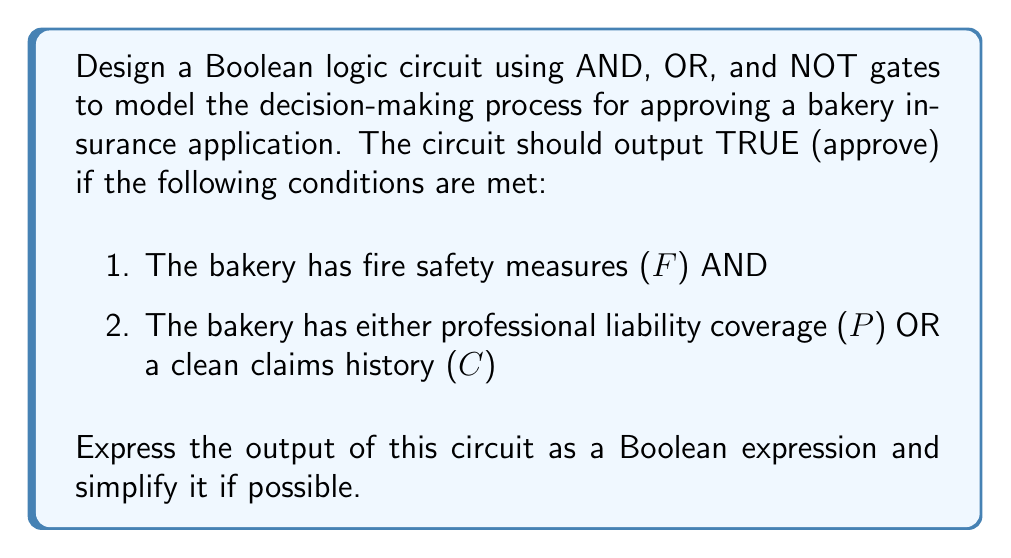Provide a solution to this math problem. Let's approach this step-by-step:

1) First, we need to translate the given conditions into a Boolean expression:

   Output = F AND (P OR C)

2) This can be represented in Boolean algebra as:

   $$Output = F \cdot (P + C)$$

3) To create a logic circuit for this expression:
   - We need an OR gate for (P + C)
   - We need an AND gate to combine F with the result of (P + C)

4) The circuit would look like this:

   [asy]
   import geometry;

   // Define points
   pair A = (0,0), B = (0,40), C = (40,20), D = (80,20), E = (120,20);

   // Draw OR gate
   draw(A--B--C--cycle);
   label("OR", (20,20));

   // Draw AND gate
   draw(D--E--(120,40)--(80,40)--cycle);
   path p = (80,30)..(100,20)..(80,10);
   draw(p);
   label("AND", (100,30));

   // Draw inputs and output
   draw((-20,0)--(0,0), arrow=Arrow(TeXHead));
   draw((-20,40)--(0,40), arrow=Arrow(TeXHead));
   draw((40,20)--(80,10), arrow=Arrow(TeXHead));
   draw((-20,70)--(80,70)--(80,30), arrow=Arrow(TeXHead));
   draw((120,20)--(140,20), arrow=Arrow(TeXHead));

   // Label inputs and output
   label("P", (-25,0));
   label("C", (-25,40));
   label("F", (-25,70));
   label("Output", (145,20));
   [/asy]

5) This Boolean expression $$F \cdot (P + C)$$ is already in its simplest form. It cannot be further simplified using Boolean algebra laws.
Answer: $$F \cdot (P + C)$$ 